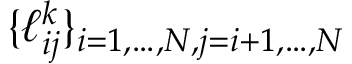<formula> <loc_0><loc_0><loc_500><loc_500>\{ \ell _ { i j } ^ { k } \} _ { i = 1 , \dots , N , j = i + 1 , \dots , N }</formula> 